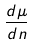Convert formula to latex. <formula><loc_0><loc_0><loc_500><loc_500>\frac { d \mu } { d n }</formula> 